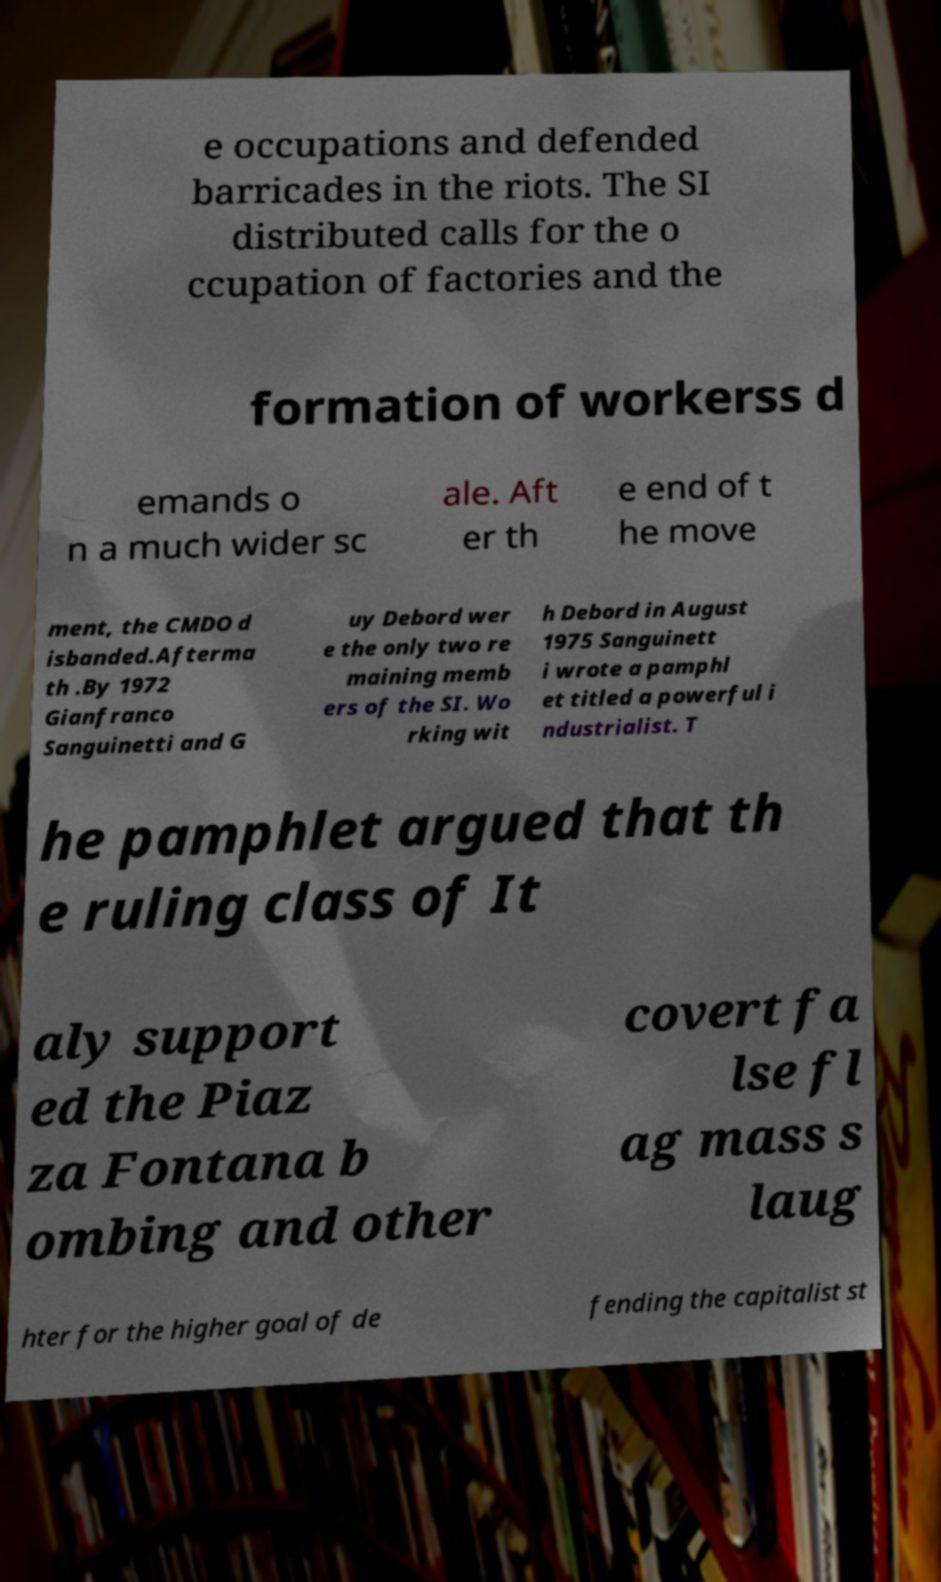There's text embedded in this image that I need extracted. Can you transcribe it verbatim? e occupations and defended barricades in the riots. The SI distributed calls for the o ccupation of factories and the formation of workerss d emands o n a much wider sc ale. Aft er th e end of t he move ment, the CMDO d isbanded.Afterma th .By 1972 Gianfranco Sanguinetti and G uy Debord wer e the only two re maining memb ers of the SI. Wo rking wit h Debord in August 1975 Sanguinett i wrote a pamphl et titled a powerful i ndustrialist. T he pamphlet argued that th e ruling class of It aly support ed the Piaz za Fontana b ombing and other covert fa lse fl ag mass s laug hter for the higher goal of de fending the capitalist st 